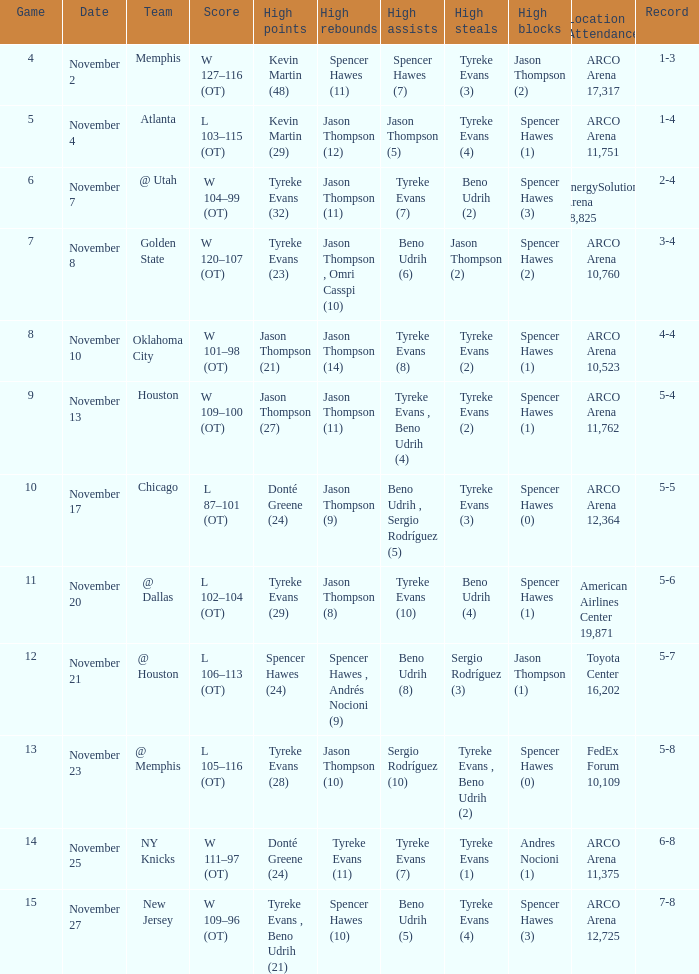If the record is 5-8, what is the team name? @ Memphis. 